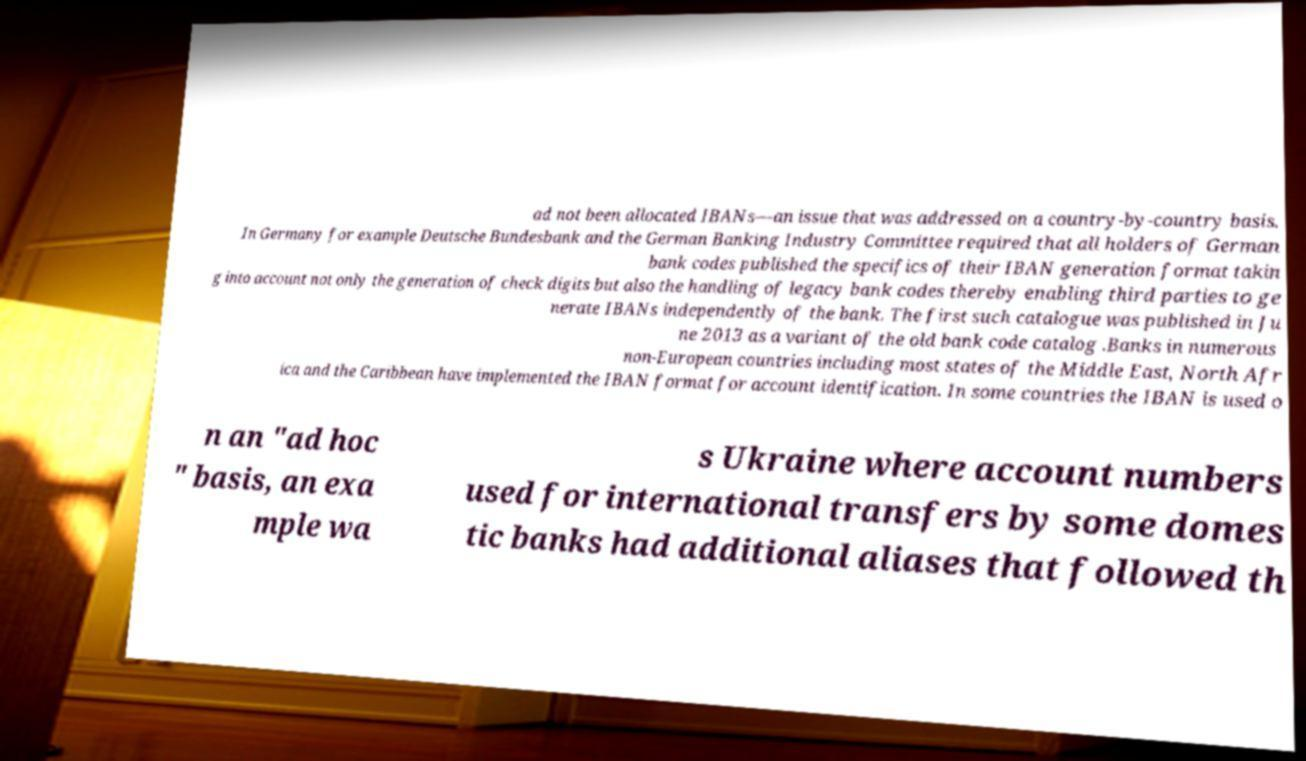For documentation purposes, I need the text within this image transcribed. Could you provide that? ad not been allocated IBANs—an issue that was addressed on a country-by-country basis. In Germany for example Deutsche Bundesbank and the German Banking Industry Committee required that all holders of German bank codes published the specifics of their IBAN generation format takin g into account not only the generation of check digits but also the handling of legacy bank codes thereby enabling third parties to ge nerate IBANs independently of the bank. The first such catalogue was published in Ju ne 2013 as a variant of the old bank code catalog .Banks in numerous non-European countries including most states of the Middle East, North Afr ica and the Caribbean have implemented the IBAN format for account identification. In some countries the IBAN is used o n an "ad hoc " basis, an exa mple wa s Ukraine where account numbers used for international transfers by some domes tic banks had additional aliases that followed th 